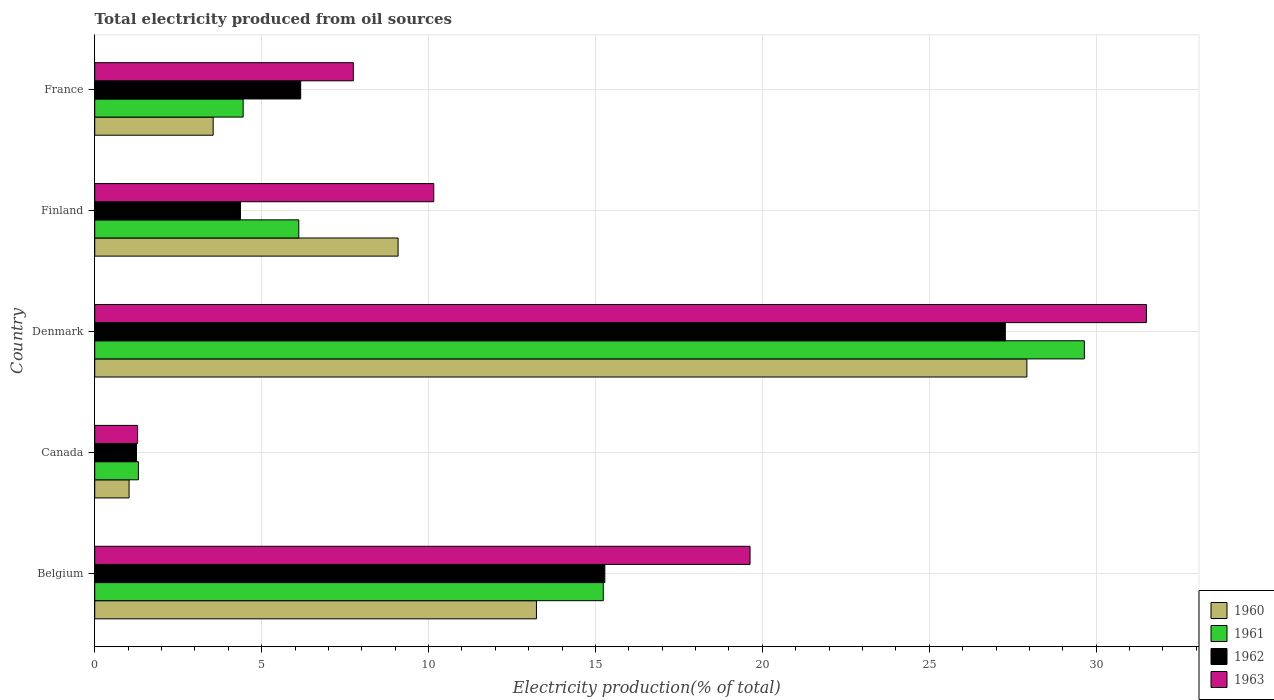How many different coloured bars are there?
Offer a terse response. 4. How many groups of bars are there?
Offer a terse response. 5. Are the number of bars per tick equal to the number of legend labels?
Offer a terse response. Yes. What is the label of the 2nd group of bars from the top?
Make the answer very short. Finland. In how many cases, is the number of bars for a given country not equal to the number of legend labels?
Offer a very short reply. 0. What is the total electricity produced in 1960 in Finland?
Offer a terse response. 9.09. Across all countries, what is the maximum total electricity produced in 1962?
Ensure brevity in your answer.  27.28. Across all countries, what is the minimum total electricity produced in 1960?
Offer a terse response. 1.03. What is the total total electricity produced in 1960 in the graph?
Offer a very short reply. 54.82. What is the difference between the total electricity produced in 1961 in Denmark and that in Finland?
Give a very brief answer. 23.53. What is the difference between the total electricity produced in 1960 in Denmark and the total electricity produced in 1963 in Finland?
Ensure brevity in your answer.  17.77. What is the average total electricity produced in 1962 per country?
Keep it short and to the point. 10.87. What is the difference between the total electricity produced in 1963 and total electricity produced in 1961 in France?
Give a very brief answer. 3.3. In how many countries, is the total electricity produced in 1962 greater than 30 %?
Offer a terse response. 0. What is the ratio of the total electricity produced in 1962 in Belgium to that in Canada?
Offer a very short reply. 12.21. Is the total electricity produced in 1962 in Finland less than that in France?
Offer a terse response. Yes. What is the difference between the highest and the second highest total electricity produced in 1960?
Your response must be concise. 14.69. What is the difference between the highest and the lowest total electricity produced in 1962?
Give a very brief answer. 26.03. In how many countries, is the total electricity produced in 1960 greater than the average total electricity produced in 1960 taken over all countries?
Keep it short and to the point. 2. Is the sum of the total electricity produced in 1962 in Canada and Finland greater than the maximum total electricity produced in 1960 across all countries?
Offer a terse response. No. What does the 2nd bar from the top in Canada represents?
Ensure brevity in your answer.  1962. What does the 2nd bar from the bottom in Finland represents?
Your response must be concise. 1961. Is it the case that in every country, the sum of the total electricity produced in 1960 and total electricity produced in 1962 is greater than the total electricity produced in 1963?
Provide a short and direct response. Yes. Are all the bars in the graph horizontal?
Offer a terse response. Yes. What is the difference between two consecutive major ticks on the X-axis?
Provide a succinct answer. 5. Does the graph contain any zero values?
Your answer should be very brief. No. Does the graph contain grids?
Your answer should be very brief. Yes. How are the legend labels stacked?
Make the answer very short. Vertical. What is the title of the graph?
Your answer should be very brief. Total electricity produced from oil sources. What is the label or title of the X-axis?
Offer a very short reply. Electricity production(% of total). What is the Electricity production(% of total) in 1960 in Belgium?
Provide a succinct answer. 13.23. What is the Electricity production(% of total) of 1961 in Belgium?
Ensure brevity in your answer.  15.23. What is the Electricity production(% of total) in 1962 in Belgium?
Offer a terse response. 15.28. What is the Electricity production(% of total) of 1963 in Belgium?
Provide a short and direct response. 19.63. What is the Electricity production(% of total) of 1960 in Canada?
Ensure brevity in your answer.  1.03. What is the Electricity production(% of total) in 1961 in Canada?
Make the answer very short. 1.31. What is the Electricity production(% of total) of 1962 in Canada?
Your answer should be very brief. 1.25. What is the Electricity production(% of total) of 1963 in Canada?
Keep it short and to the point. 1.28. What is the Electricity production(% of total) of 1960 in Denmark?
Your response must be concise. 27.92. What is the Electricity production(% of total) in 1961 in Denmark?
Your answer should be compact. 29.65. What is the Electricity production(% of total) in 1962 in Denmark?
Your answer should be very brief. 27.28. What is the Electricity production(% of total) of 1963 in Denmark?
Provide a succinct answer. 31.51. What is the Electricity production(% of total) of 1960 in Finland?
Provide a succinct answer. 9.09. What is the Electricity production(% of total) in 1961 in Finland?
Offer a terse response. 6.11. What is the Electricity production(% of total) in 1962 in Finland?
Your response must be concise. 4.36. What is the Electricity production(% of total) in 1963 in Finland?
Offer a terse response. 10.16. What is the Electricity production(% of total) in 1960 in France?
Your answer should be compact. 3.55. What is the Electricity production(% of total) of 1961 in France?
Make the answer very short. 4.45. What is the Electricity production(% of total) of 1962 in France?
Your response must be concise. 6.17. What is the Electricity production(% of total) in 1963 in France?
Your answer should be compact. 7.75. Across all countries, what is the maximum Electricity production(% of total) of 1960?
Make the answer very short. 27.92. Across all countries, what is the maximum Electricity production(% of total) of 1961?
Give a very brief answer. 29.65. Across all countries, what is the maximum Electricity production(% of total) of 1962?
Provide a succinct answer. 27.28. Across all countries, what is the maximum Electricity production(% of total) in 1963?
Give a very brief answer. 31.51. Across all countries, what is the minimum Electricity production(% of total) in 1960?
Provide a short and direct response. 1.03. Across all countries, what is the minimum Electricity production(% of total) of 1961?
Offer a terse response. 1.31. Across all countries, what is the minimum Electricity production(% of total) of 1962?
Your answer should be compact. 1.25. Across all countries, what is the minimum Electricity production(% of total) of 1963?
Give a very brief answer. 1.28. What is the total Electricity production(% of total) of 1960 in the graph?
Offer a terse response. 54.82. What is the total Electricity production(% of total) of 1961 in the graph?
Ensure brevity in your answer.  56.75. What is the total Electricity production(% of total) in 1962 in the graph?
Your answer should be compact. 54.34. What is the total Electricity production(% of total) of 1963 in the graph?
Offer a terse response. 70.32. What is the difference between the Electricity production(% of total) of 1960 in Belgium and that in Canada?
Your answer should be very brief. 12.2. What is the difference between the Electricity production(% of total) in 1961 in Belgium and that in Canada?
Your answer should be very brief. 13.93. What is the difference between the Electricity production(% of total) of 1962 in Belgium and that in Canada?
Provide a short and direct response. 14.03. What is the difference between the Electricity production(% of total) of 1963 in Belgium and that in Canada?
Ensure brevity in your answer.  18.35. What is the difference between the Electricity production(% of total) of 1960 in Belgium and that in Denmark?
Your answer should be very brief. -14.69. What is the difference between the Electricity production(% of total) in 1961 in Belgium and that in Denmark?
Your answer should be compact. -14.41. What is the difference between the Electricity production(% of total) in 1962 in Belgium and that in Denmark?
Ensure brevity in your answer.  -12. What is the difference between the Electricity production(% of total) in 1963 in Belgium and that in Denmark?
Offer a terse response. -11.87. What is the difference between the Electricity production(% of total) of 1960 in Belgium and that in Finland?
Make the answer very short. 4.14. What is the difference between the Electricity production(% of total) in 1961 in Belgium and that in Finland?
Provide a succinct answer. 9.12. What is the difference between the Electricity production(% of total) in 1962 in Belgium and that in Finland?
Your answer should be compact. 10.92. What is the difference between the Electricity production(% of total) of 1963 in Belgium and that in Finland?
Provide a short and direct response. 9.47. What is the difference between the Electricity production(% of total) of 1960 in Belgium and that in France?
Your answer should be compact. 9.68. What is the difference between the Electricity production(% of total) of 1961 in Belgium and that in France?
Give a very brief answer. 10.79. What is the difference between the Electricity production(% of total) in 1962 in Belgium and that in France?
Your answer should be very brief. 9.11. What is the difference between the Electricity production(% of total) in 1963 in Belgium and that in France?
Provide a short and direct response. 11.88. What is the difference between the Electricity production(% of total) in 1960 in Canada and that in Denmark?
Offer a very short reply. -26.9. What is the difference between the Electricity production(% of total) in 1961 in Canada and that in Denmark?
Your answer should be compact. -28.34. What is the difference between the Electricity production(% of total) in 1962 in Canada and that in Denmark?
Provide a short and direct response. -26.03. What is the difference between the Electricity production(% of total) in 1963 in Canada and that in Denmark?
Give a very brief answer. -30.22. What is the difference between the Electricity production(% of total) in 1960 in Canada and that in Finland?
Ensure brevity in your answer.  -8.06. What is the difference between the Electricity production(% of total) in 1961 in Canada and that in Finland?
Ensure brevity in your answer.  -4.8. What is the difference between the Electricity production(% of total) of 1962 in Canada and that in Finland?
Offer a terse response. -3.11. What is the difference between the Electricity production(% of total) in 1963 in Canada and that in Finland?
Your answer should be very brief. -8.87. What is the difference between the Electricity production(% of total) of 1960 in Canada and that in France?
Your answer should be compact. -2.52. What is the difference between the Electricity production(% of total) of 1961 in Canada and that in France?
Your answer should be very brief. -3.14. What is the difference between the Electricity production(% of total) of 1962 in Canada and that in France?
Provide a succinct answer. -4.92. What is the difference between the Electricity production(% of total) in 1963 in Canada and that in France?
Give a very brief answer. -6.46. What is the difference between the Electricity production(% of total) of 1960 in Denmark and that in Finland?
Give a very brief answer. 18.84. What is the difference between the Electricity production(% of total) in 1961 in Denmark and that in Finland?
Offer a terse response. 23.53. What is the difference between the Electricity production(% of total) of 1962 in Denmark and that in Finland?
Give a very brief answer. 22.91. What is the difference between the Electricity production(% of total) in 1963 in Denmark and that in Finland?
Your answer should be very brief. 21.35. What is the difference between the Electricity production(% of total) of 1960 in Denmark and that in France?
Offer a very short reply. 24.38. What is the difference between the Electricity production(% of total) in 1961 in Denmark and that in France?
Your answer should be very brief. 25.2. What is the difference between the Electricity production(% of total) in 1962 in Denmark and that in France?
Make the answer very short. 21.11. What is the difference between the Electricity production(% of total) of 1963 in Denmark and that in France?
Ensure brevity in your answer.  23.76. What is the difference between the Electricity production(% of total) of 1960 in Finland and that in France?
Keep it short and to the point. 5.54. What is the difference between the Electricity production(% of total) of 1961 in Finland and that in France?
Your answer should be very brief. 1.67. What is the difference between the Electricity production(% of total) in 1962 in Finland and that in France?
Your answer should be very brief. -1.8. What is the difference between the Electricity production(% of total) in 1963 in Finland and that in France?
Ensure brevity in your answer.  2.41. What is the difference between the Electricity production(% of total) of 1960 in Belgium and the Electricity production(% of total) of 1961 in Canada?
Provide a short and direct response. 11.92. What is the difference between the Electricity production(% of total) of 1960 in Belgium and the Electricity production(% of total) of 1962 in Canada?
Give a very brief answer. 11.98. What is the difference between the Electricity production(% of total) of 1960 in Belgium and the Electricity production(% of total) of 1963 in Canada?
Keep it short and to the point. 11.95. What is the difference between the Electricity production(% of total) of 1961 in Belgium and the Electricity production(% of total) of 1962 in Canada?
Ensure brevity in your answer.  13.98. What is the difference between the Electricity production(% of total) in 1961 in Belgium and the Electricity production(% of total) in 1963 in Canada?
Provide a short and direct response. 13.95. What is the difference between the Electricity production(% of total) of 1962 in Belgium and the Electricity production(% of total) of 1963 in Canada?
Your answer should be compact. 14. What is the difference between the Electricity production(% of total) in 1960 in Belgium and the Electricity production(% of total) in 1961 in Denmark?
Offer a very short reply. -16.41. What is the difference between the Electricity production(% of total) of 1960 in Belgium and the Electricity production(% of total) of 1962 in Denmark?
Provide a succinct answer. -14.05. What is the difference between the Electricity production(% of total) of 1960 in Belgium and the Electricity production(% of total) of 1963 in Denmark?
Your response must be concise. -18.27. What is the difference between the Electricity production(% of total) of 1961 in Belgium and the Electricity production(% of total) of 1962 in Denmark?
Ensure brevity in your answer.  -12.04. What is the difference between the Electricity production(% of total) of 1961 in Belgium and the Electricity production(% of total) of 1963 in Denmark?
Offer a very short reply. -16.27. What is the difference between the Electricity production(% of total) in 1962 in Belgium and the Electricity production(% of total) in 1963 in Denmark?
Give a very brief answer. -16.22. What is the difference between the Electricity production(% of total) in 1960 in Belgium and the Electricity production(% of total) in 1961 in Finland?
Your response must be concise. 7.12. What is the difference between the Electricity production(% of total) in 1960 in Belgium and the Electricity production(% of total) in 1962 in Finland?
Your answer should be compact. 8.87. What is the difference between the Electricity production(% of total) in 1960 in Belgium and the Electricity production(% of total) in 1963 in Finland?
Your response must be concise. 3.08. What is the difference between the Electricity production(% of total) of 1961 in Belgium and the Electricity production(% of total) of 1962 in Finland?
Offer a very short reply. 10.87. What is the difference between the Electricity production(% of total) in 1961 in Belgium and the Electricity production(% of total) in 1963 in Finland?
Offer a terse response. 5.08. What is the difference between the Electricity production(% of total) of 1962 in Belgium and the Electricity production(% of total) of 1963 in Finland?
Your response must be concise. 5.12. What is the difference between the Electricity production(% of total) of 1960 in Belgium and the Electricity production(% of total) of 1961 in France?
Offer a terse response. 8.79. What is the difference between the Electricity production(% of total) in 1960 in Belgium and the Electricity production(% of total) in 1962 in France?
Provide a short and direct response. 7.06. What is the difference between the Electricity production(% of total) of 1960 in Belgium and the Electricity production(% of total) of 1963 in France?
Provide a short and direct response. 5.48. What is the difference between the Electricity production(% of total) of 1961 in Belgium and the Electricity production(% of total) of 1962 in France?
Offer a terse response. 9.07. What is the difference between the Electricity production(% of total) of 1961 in Belgium and the Electricity production(% of total) of 1963 in France?
Your response must be concise. 7.49. What is the difference between the Electricity production(% of total) of 1962 in Belgium and the Electricity production(% of total) of 1963 in France?
Provide a short and direct response. 7.53. What is the difference between the Electricity production(% of total) in 1960 in Canada and the Electricity production(% of total) in 1961 in Denmark?
Offer a terse response. -28.62. What is the difference between the Electricity production(% of total) of 1960 in Canada and the Electricity production(% of total) of 1962 in Denmark?
Ensure brevity in your answer.  -26.25. What is the difference between the Electricity production(% of total) of 1960 in Canada and the Electricity production(% of total) of 1963 in Denmark?
Make the answer very short. -30.48. What is the difference between the Electricity production(% of total) in 1961 in Canada and the Electricity production(% of total) in 1962 in Denmark?
Make the answer very short. -25.97. What is the difference between the Electricity production(% of total) in 1961 in Canada and the Electricity production(% of total) in 1963 in Denmark?
Ensure brevity in your answer.  -30.2. What is the difference between the Electricity production(% of total) of 1962 in Canada and the Electricity production(% of total) of 1963 in Denmark?
Your answer should be compact. -30.25. What is the difference between the Electricity production(% of total) of 1960 in Canada and the Electricity production(% of total) of 1961 in Finland?
Offer a terse response. -5.08. What is the difference between the Electricity production(% of total) of 1960 in Canada and the Electricity production(% of total) of 1962 in Finland?
Provide a succinct answer. -3.34. What is the difference between the Electricity production(% of total) of 1960 in Canada and the Electricity production(% of total) of 1963 in Finland?
Your answer should be compact. -9.13. What is the difference between the Electricity production(% of total) in 1961 in Canada and the Electricity production(% of total) in 1962 in Finland?
Ensure brevity in your answer.  -3.06. What is the difference between the Electricity production(% of total) in 1961 in Canada and the Electricity production(% of total) in 1963 in Finland?
Provide a succinct answer. -8.85. What is the difference between the Electricity production(% of total) in 1962 in Canada and the Electricity production(% of total) in 1963 in Finland?
Your answer should be very brief. -8.91. What is the difference between the Electricity production(% of total) of 1960 in Canada and the Electricity production(% of total) of 1961 in France?
Your answer should be compact. -3.42. What is the difference between the Electricity production(% of total) of 1960 in Canada and the Electricity production(% of total) of 1962 in France?
Keep it short and to the point. -5.14. What is the difference between the Electricity production(% of total) of 1960 in Canada and the Electricity production(% of total) of 1963 in France?
Your response must be concise. -6.72. What is the difference between the Electricity production(% of total) in 1961 in Canada and the Electricity production(% of total) in 1962 in France?
Provide a succinct answer. -4.86. What is the difference between the Electricity production(% of total) in 1961 in Canada and the Electricity production(% of total) in 1963 in France?
Provide a succinct answer. -6.44. What is the difference between the Electricity production(% of total) in 1962 in Canada and the Electricity production(% of total) in 1963 in France?
Offer a terse response. -6.5. What is the difference between the Electricity production(% of total) of 1960 in Denmark and the Electricity production(% of total) of 1961 in Finland?
Ensure brevity in your answer.  21.81. What is the difference between the Electricity production(% of total) in 1960 in Denmark and the Electricity production(% of total) in 1962 in Finland?
Offer a terse response. 23.56. What is the difference between the Electricity production(% of total) in 1960 in Denmark and the Electricity production(% of total) in 1963 in Finland?
Ensure brevity in your answer.  17.77. What is the difference between the Electricity production(% of total) of 1961 in Denmark and the Electricity production(% of total) of 1962 in Finland?
Your answer should be very brief. 25.28. What is the difference between the Electricity production(% of total) of 1961 in Denmark and the Electricity production(% of total) of 1963 in Finland?
Keep it short and to the point. 19.49. What is the difference between the Electricity production(% of total) of 1962 in Denmark and the Electricity production(% of total) of 1963 in Finland?
Ensure brevity in your answer.  17.12. What is the difference between the Electricity production(% of total) in 1960 in Denmark and the Electricity production(% of total) in 1961 in France?
Ensure brevity in your answer.  23.48. What is the difference between the Electricity production(% of total) of 1960 in Denmark and the Electricity production(% of total) of 1962 in France?
Your answer should be very brief. 21.75. What is the difference between the Electricity production(% of total) of 1960 in Denmark and the Electricity production(% of total) of 1963 in France?
Your answer should be compact. 20.18. What is the difference between the Electricity production(% of total) in 1961 in Denmark and the Electricity production(% of total) in 1962 in France?
Make the answer very short. 23.48. What is the difference between the Electricity production(% of total) of 1961 in Denmark and the Electricity production(% of total) of 1963 in France?
Offer a terse response. 21.9. What is the difference between the Electricity production(% of total) of 1962 in Denmark and the Electricity production(% of total) of 1963 in France?
Your answer should be very brief. 19.53. What is the difference between the Electricity production(% of total) of 1960 in Finland and the Electricity production(% of total) of 1961 in France?
Your answer should be compact. 4.64. What is the difference between the Electricity production(% of total) of 1960 in Finland and the Electricity production(% of total) of 1962 in France?
Keep it short and to the point. 2.92. What is the difference between the Electricity production(% of total) in 1960 in Finland and the Electricity production(% of total) in 1963 in France?
Your answer should be very brief. 1.34. What is the difference between the Electricity production(% of total) in 1961 in Finland and the Electricity production(% of total) in 1962 in France?
Ensure brevity in your answer.  -0.06. What is the difference between the Electricity production(% of total) in 1961 in Finland and the Electricity production(% of total) in 1963 in France?
Keep it short and to the point. -1.64. What is the difference between the Electricity production(% of total) in 1962 in Finland and the Electricity production(% of total) in 1963 in France?
Your answer should be compact. -3.38. What is the average Electricity production(% of total) in 1960 per country?
Your answer should be very brief. 10.96. What is the average Electricity production(% of total) in 1961 per country?
Make the answer very short. 11.35. What is the average Electricity production(% of total) of 1962 per country?
Ensure brevity in your answer.  10.87. What is the average Electricity production(% of total) of 1963 per country?
Offer a very short reply. 14.06. What is the difference between the Electricity production(% of total) of 1960 and Electricity production(% of total) of 1961 in Belgium?
Your response must be concise. -2. What is the difference between the Electricity production(% of total) of 1960 and Electricity production(% of total) of 1962 in Belgium?
Provide a short and direct response. -2.05. What is the difference between the Electricity production(% of total) in 1960 and Electricity production(% of total) in 1963 in Belgium?
Your answer should be compact. -6.4. What is the difference between the Electricity production(% of total) of 1961 and Electricity production(% of total) of 1962 in Belgium?
Keep it short and to the point. -0.05. What is the difference between the Electricity production(% of total) in 1961 and Electricity production(% of total) in 1963 in Belgium?
Offer a very short reply. -4.4. What is the difference between the Electricity production(% of total) of 1962 and Electricity production(% of total) of 1963 in Belgium?
Offer a very short reply. -4.35. What is the difference between the Electricity production(% of total) in 1960 and Electricity production(% of total) in 1961 in Canada?
Keep it short and to the point. -0.28. What is the difference between the Electricity production(% of total) of 1960 and Electricity production(% of total) of 1962 in Canada?
Ensure brevity in your answer.  -0.22. What is the difference between the Electricity production(% of total) in 1960 and Electricity production(% of total) in 1963 in Canada?
Ensure brevity in your answer.  -0.26. What is the difference between the Electricity production(% of total) of 1961 and Electricity production(% of total) of 1962 in Canada?
Your answer should be very brief. 0.06. What is the difference between the Electricity production(% of total) in 1961 and Electricity production(% of total) in 1963 in Canada?
Keep it short and to the point. 0.03. What is the difference between the Electricity production(% of total) of 1962 and Electricity production(% of total) of 1963 in Canada?
Your answer should be very brief. -0.03. What is the difference between the Electricity production(% of total) of 1960 and Electricity production(% of total) of 1961 in Denmark?
Ensure brevity in your answer.  -1.72. What is the difference between the Electricity production(% of total) of 1960 and Electricity production(% of total) of 1962 in Denmark?
Offer a terse response. 0.65. What is the difference between the Electricity production(% of total) in 1960 and Electricity production(% of total) in 1963 in Denmark?
Your answer should be very brief. -3.58. What is the difference between the Electricity production(% of total) in 1961 and Electricity production(% of total) in 1962 in Denmark?
Provide a succinct answer. 2.37. What is the difference between the Electricity production(% of total) in 1961 and Electricity production(% of total) in 1963 in Denmark?
Offer a very short reply. -1.86. What is the difference between the Electricity production(% of total) in 1962 and Electricity production(% of total) in 1963 in Denmark?
Make the answer very short. -4.23. What is the difference between the Electricity production(% of total) of 1960 and Electricity production(% of total) of 1961 in Finland?
Keep it short and to the point. 2.98. What is the difference between the Electricity production(% of total) of 1960 and Electricity production(% of total) of 1962 in Finland?
Provide a succinct answer. 4.72. What is the difference between the Electricity production(% of total) in 1960 and Electricity production(% of total) in 1963 in Finland?
Ensure brevity in your answer.  -1.07. What is the difference between the Electricity production(% of total) in 1961 and Electricity production(% of total) in 1962 in Finland?
Ensure brevity in your answer.  1.75. What is the difference between the Electricity production(% of total) of 1961 and Electricity production(% of total) of 1963 in Finland?
Make the answer very short. -4.04. What is the difference between the Electricity production(% of total) in 1962 and Electricity production(% of total) in 1963 in Finland?
Make the answer very short. -5.79. What is the difference between the Electricity production(% of total) in 1960 and Electricity production(% of total) in 1961 in France?
Offer a very short reply. -0.9. What is the difference between the Electricity production(% of total) of 1960 and Electricity production(% of total) of 1962 in France?
Keep it short and to the point. -2.62. What is the difference between the Electricity production(% of total) in 1960 and Electricity production(% of total) in 1963 in France?
Keep it short and to the point. -4.2. What is the difference between the Electricity production(% of total) in 1961 and Electricity production(% of total) in 1962 in France?
Make the answer very short. -1.72. What is the difference between the Electricity production(% of total) in 1961 and Electricity production(% of total) in 1963 in France?
Your response must be concise. -3.3. What is the difference between the Electricity production(% of total) in 1962 and Electricity production(% of total) in 1963 in France?
Provide a short and direct response. -1.58. What is the ratio of the Electricity production(% of total) of 1960 in Belgium to that in Canada?
Your response must be concise. 12.86. What is the ratio of the Electricity production(% of total) of 1961 in Belgium to that in Canada?
Your answer should be compact. 11.64. What is the ratio of the Electricity production(% of total) in 1962 in Belgium to that in Canada?
Your response must be concise. 12.21. What is the ratio of the Electricity production(% of total) in 1963 in Belgium to that in Canada?
Ensure brevity in your answer.  15.29. What is the ratio of the Electricity production(% of total) in 1960 in Belgium to that in Denmark?
Offer a terse response. 0.47. What is the ratio of the Electricity production(% of total) of 1961 in Belgium to that in Denmark?
Your answer should be compact. 0.51. What is the ratio of the Electricity production(% of total) of 1962 in Belgium to that in Denmark?
Keep it short and to the point. 0.56. What is the ratio of the Electricity production(% of total) in 1963 in Belgium to that in Denmark?
Your answer should be compact. 0.62. What is the ratio of the Electricity production(% of total) of 1960 in Belgium to that in Finland?
Your response must be concise. 1.46. What is the ratio of the Electricity production(% of total) of 1961 in Belgium to that in Finland?
Offer a very short reply. 2.49. What is the ratio of the Electricity production(% of total) in 1962 in Belgium to that in Finland?
Your answer should be compact. 3.5. What is the ratio of the Electricity production(% of total) of 1963 in Belgium to that in Finland?
Your response must be concise. 1.93. What is the ratio of the Electricity production(% of total) of 1960 in Belgium to that in France?
Ensure brevity in your answer.  3.73. What is the ratio of the Electricity production(% of total) in 1961 in Belgium to that in France?
Your answer should be compact. 3.43. What is the ratio of the Electricity production(% of total) of 1962 in Belgium to that in France?
Your response must be concise. 2.48. What is the ratio of the Electricity production(% of total) of 1963 in Belgium to that in France?
Your response must be concise. 2.53. What is the ratio of the Electricity production(% of total) in 1960 in Canada to that in Denmark?
Ensure brevity in your answer.  0.04. What is the ratio of the Electricity production(% of total) of 1961 in Canada to that in Denmark?
Your answer should be very brief. 0.04. What is the ratio of the Electricity production(% of total) in 1962 in Canada to that in Denmark?
Your answer should be very brief. 0.05. What is the ratio of the Electricity production(% of total) of 1963 in Canada to that in Denmark?
Ensure brevity in your answer.  0.04. What is the ratio of the Electricity production(% of total) in 1960 in Canada to that in Finland?
Give a very brief answer. 0.11. What is the ratio of the Electricity production(% of total) in 1961 in Canada to that in Finland?
Ensure brevity in your answer.  0.21. What is the ratio of the Electricity production(% of total) in 1962 in Canada to that in Finland?
Keep it short and to the point. 0.29. What is the ratio of the Electricity production(% of total) of 1963 in Canada to that in Finland?
Offer a very short reply. 0.13. What is the ratio of the Electricity production(% of total) in 1960 in Canada to that in France?
Provide a short and direct response. 0.29. What is the ratio of the Electricity production(% of total) in 1961 in Canada to that in France?
Your answer should be compact. 0.29. What is the ratio of the Electricity production(% of total) of 1962 in Canada to that in France?
Keep it short and to the point. 0.2. What is the ratio of the Electricity production(% of total) of 1963 in Canada to that in France?
Keep it short and to the point. 0.17. What is the ratio of the Electricity production(% of total) of 1960 in Denmark to that in Finland?
Your answer should be very brief. 3.07. What is the ratio of the Electricity production(% of total) of 1961 in Denmark to that in Finland?
Your answer should be very brief. 4.85. What is the ratio of the Electricity production(% of total) in 1962 in Denmark to that in Finland?
Provide a short and direct response. 6.25. What is the ratio of the Electricity production(% of total) in 1963 in Denmark to that in Finland?
Your answer should be very brief. 3.1. What is the ratio of the Electricity production(% of total) in 1960 in Denmark to that in France?
Keep it short and to the point. 7.87. What is the ratio of the Electricity production(% of total) in 1961 in Denmark to that in France?
Provide a succinct answer. 6.67. What is the ratio of the Electricity production(% of total) in 1962 in Denmark to that in France?
Give a very brief answer. 4.42. What is the ratio of the Electricity production(% of total) of 1963 in Denmark to that in France?
Make the answer very short. 4.07. What is the ratio of the Electricity production(% of total) of 1960 in Finland to that in France?
Ensure brevity in your answer.  2.56. What is the ratio of the Electricity production(% of total) of 1961 in Finland to that in France?
Provide a succinct answer. 1.37. What is the ratio of the Electricity production(% of total) of 1962 in Finland to that in France?
Your answer should be compact. 0.71. What is the ratio of the Electricity production(% of total) of 1963 in Finland to that in France?
Keep it short and to the point. 1.31. What is the difference between the highest and the second highest Electricity production(% of total) in 1960?
Provide a short and direct response. 14.69. What is the difference between the highest and the second highest Electricity production(% of total) of 1961?
Offer a terse response. 14.41. What is the difference between the highest and the second highest Electricity production(% of total) in 1962?
Provide a succinct answer. 12. What is the difference between the highest and the second highest Electricity production(% of total) in 1963?
Keep it short and to the point. 11.87. What is the difference between the highest and the lowest Electricity production(% of total) of 1960?
Offer a very short reply. 26.9. What is the difference between the highest and the lowest Electricity production(% of total) in 1961?
Keep it short and to the point. 28.34. What is the difference between the highest and the lowest Electricity production(% of total) in 1962?
Your answer should be very brief. 26.03. What is the difference between the highest and the lowest Electricity production(% of total) of 1963?
Your response must be concise. 30.22. 